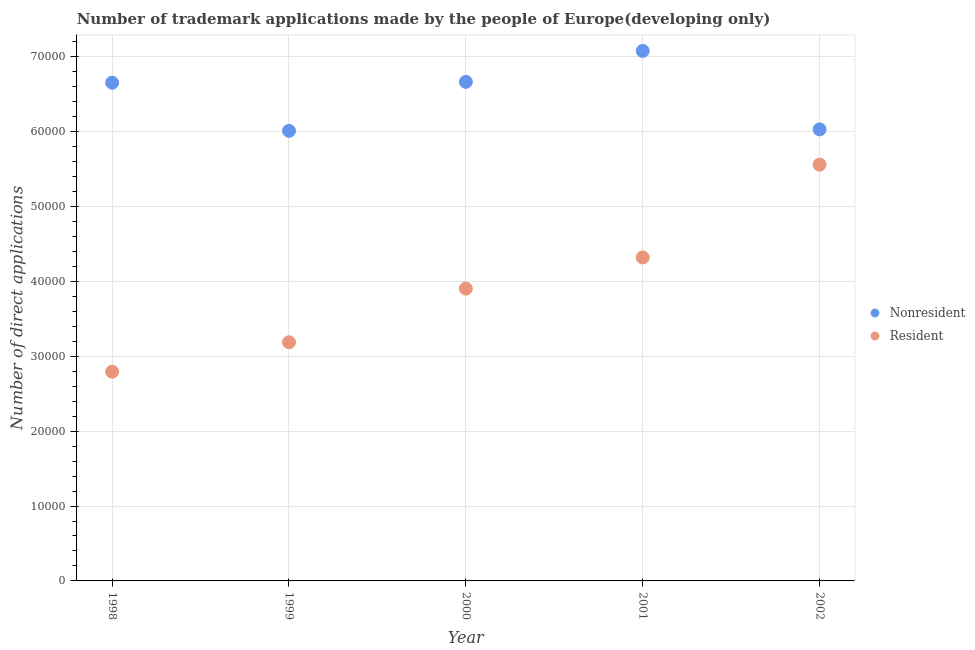What is the number of trademark applications made by residents in 2002?
Offer a very short reply. 5.56e+04. Across all years, what is the maximum number of trademark applications made by residents?
Your answer should be compact. 5.56e+04. Across all years, what is the minimum number of trademark applications made by residents?
Give a very brief answer. 2.79e+04. What is the total number of trademark applications made by residents in the graph?
Keep it short and to the point. 1.98e+05. What is the difference between the number of trademark applications made by non residents in 2001 and that in 2002?
Your response must be concise. 1.05e+04. What is the difference between the number of trademark applications made by residents in 2001 and the number of trademark applications made by non residents in 2000?
Provide a succinct answer. -2.35e+04. What is the average number of trademark applications made by residents per year?
Provide a short and direct response. 3.95e+04. In the year 2002, what is the difference between the number of trademark applications made by non residents and number of trademark applications made by residents?
Provide a succinct answer. 4712. What is the ratio of the number of trademark applications made by residents in 1999 to that in 2000?
Your response must be concise. 0.82. Is the number of trademark applications made by non residents in 2000 less than that in 2002?
Your response must be concise. No. What is the difference between the highest and the second highest number of trademark applications made by non residents?
Make the answer very short. 4131. What is the difference between the highest and the lowest number of trademark applications made by non residents?
Your answer should be very brief. 1.07e+04. Does the graph contain any zero values?
Your answer should be very brief. No. Does the graph contain grids?
Keep it short and to the point. Yes. Where does the legend appear in the graph?
Provide a short and direct response. Center right. How many legend labels are there?
Give a very brief answer. 2. What is the title of the graph?
Provide a succinct answer. Number of trademark applications made by the people of Europe(developing only). Does "Domestic Liabilities" appear as one of the legend labels in the graph?
Provide a succinct answer. No. What is the label or title of the Y-axis?
Your answer should be compact. Number of direct applications. What is the Number of direct applications of Nonresident in 1998?
Make the answer very short. 6.65e+04. What is the Number of direct applications of Resident in 1998?
Your answer should be very brief. 2.79e+04. What is the Number of direct applications of Nonresident in 1999?
Your answer should be very brief. 6.01e+04. What is the Number of direct applications of Resident in 1999?
Give a very brief answer. 3.19e+04. What is the Number of direct applications of Nonresident in 2000?
Provide a short and direct response. 6.66e+04. What is the Number of direct applications of Resident in 2000?
Your answer should be very brief. 3.90e+04. What is the Number of direct applications of Nonresident in 2001?
Provide a succinct answer. 7.08e+04. What is the Number of direct applications of Resident in 2001?
Provide a short and direct response. 4.32e+04. What is the Number of direct applications of Nonresident in 2002?
Your answer should be very brief. 6.03e+04. What is the Number of direct applications of Resident in 2002?
Give a very brief answer. 5.56e+04. Across all years, what is the maximum Number of direct applications in Nonresident?
Ensure brevity in your answer.  7.08e+04. Across all years, what is the maximum Number of direct applications in Resident?
Make the answer very short. 5.56e+04. Across all years, what is the minimum Number of direct applications in Nonresident?
Offer a very short reply. 6.01e+04. Across all years, what is the minimum Number of direct applications of Resident?
Offer a terse response. 2.79e+04. What is the total Number of direct applications in Nonresident in the graph?
Your answer should be very brief. 3.24e+05. What is the total Number of direct applications of Resident in the graph?
Give a very brief answer. 1.98e+05. What is the difference between the Number of direct applications in Nonresident in 1998 and that in 1999?
Ensure brevity in your answer.  6429. What is the difference between the Number of direct applications of Resident in 1998 and that in 1999?
Make the answer very short. -3927. What is the difference between the Number of direct applications of Nonresident in 1998 and that in 2000?
Your answer should be very brief. -114. What is the difference between the Number of direct applications in Resident in 1998 and that in 2000?
Offer a terse response. -1.11e+04. What is the difference between the Number of direct applications of Nonresident in 1998 and that in 2001?
Provide a short and direct response. -4245. What is the difference between the Number of direct applications in Resident in 1998 and that in 2001?
Give a very brief answer. -1.53e+04. What is the difference between the Number of direct applications in Nonresident in 1998 and that in 2002?
Your response must be concise. 6230. What is the difference between the Number of direct applications of Resident in 1998 and that in 2002?
Give a very brief answer. -2.77e+04. What is the difference between the Number of direct applications of Nonresident in 1999 and that in 2000?
Keep it short and to the point. -6543. What is the difference between the Number of direct applications of Resident in 1999 and that in 2000?
Ensure brevity in your answer.  -7171. What is the difference between the Number of direct applications in Nonresident in 1999 and that in 2001?
Provide a succinct answer. -1.07e+04. What is the difference between the Number of direct applications in Resident in 1999 and that in 2001?
Offer a terse response. -1.13e+04. What is the difference between the Number of direct applications in Nonresident in 1999 and that in 2002?
Your response must be concise. -199. What is the difference between the Number of direct applications of Resident in 1999 and that in 2002?
Ensure brevity in your answer.  -2.37e+04. What is the difference between the Number of direct applications of Nonresident in 2000 and that in 2001?
Provide a succinct answer. -4131. What is the difference between the Number of direct applications in Resident in 2000 and that in 2001?
Your response must be concise. -4157. What is the difference between the Number of direct applications in Nonresident in 2000 and that in 2002?
Offer a terse response. 6344. What is the difference between the Number of direct applications in Resident in 2000 and that in 2002?
Offer a very short reply. -1.66e+04. What is the difference between the Number of direct applications in Nonresident in 2001 and that in 2002?
Make the answer very short. 1.05e+04. What is the difference between the Number of direct applications in Resident in 2001 and that in 2002?
Provide a short and direct response. -1.24e+04. What is the difference between the Number of direct applications of Nonresident in 1998 and the Number of direct applications of Resident in 1999?
Your response must be concise. 3.47e+04. What is the difference between the Number of direct applications of Nonresident in 1998 and the Number of direct applications of Resident in 2000?
Provide a short and direct response. 2.75e+04. What is the difference between the Number of direct applications of Nonresident in 1998 and the Number of direct applications of Resident in 2001?
Make the answer very short. 2.33e+04. What is the difference between the Number of direct applications in Nonresident in 1998 and the Number of direct applications in Resident in 2002?
Your answer should be very brief. 1.09e+04. What is the difference between the Number of direct applications in Nonresident in 1999 and the Number of direct applications in Resident in 2000?
Ensure brevity in your answer.  2.11e+04. What is the difference between the Number of direct applications in Nonresident in 1999 and the Number of direct applications in Resident in 2001?
Make the answer very short. 1.69e+04. What is the difference between the Number of direct applications in Nonresident in 1999 and the Number of direct applications in Resident in 2002?
Provide a short and direct response. 4513. What is the difference between the Number of direct applications of Nonresident in 2000 and the Number of direct applications of Resident in 2001?
Keep it short and to the point. 2.35e+04. What is the difference between the Number of direct applications in Nonresident in 2000 and the Number of direct applications in Resident in 2002?
Keep it short and to the point. 1.11e+04. What is the difference between the Number of direct applications in Nonresident in 2001 and the Number of direct applications in Resident in 2002?
Your answer should be very brief. 1.52e+04. What is the average Number of direct applications of Nonresident per year?
Offer a terse response. 6.49e+04. What is the average Number of direct applications in Resident per year?
Offer a very short reply. 3.95e+04. In the year 1998, what is the difference between the Number of direct applications in Nonresident and Number of direct applications in Resident?
Your answer should be compact. 3.86e+04. In the year 1999, what is the difference between the Number of direct applications in Nonresident and Number of direct applications in Resident?
Your answer should be compact. 2.82e+04. In the year 2000, what is the difference between the Number of direct applications in Nonresident and Number of direct applications in Resident?
Keep it short and to the point. 2.76e+04. In the year 2001, what is the difference between the Number of direct applications of Nonresident and Number of direct applications of Resident?
Keep it short and to the point. 2.76e+04. In the year 2002, what is the difference between the Number of direct applications in Nonresident and Number of direct applications in Resident?
Keep it short and to the point. 4712. What is the ratio of the Number of direct applications in Nonresident in 1998 to that in 1999?
Your answer should be very brief. 1.11. What is the ratio of the Number of direct applications in Resident in 1998 to that in 1999?
Your answer should be compact. 0.88. What is the ratio of the Number of direct applications of Nonresident in 1998 to that in 2000?
Ensure brevity in your answer.  1. What is the ratio of the Number of direct applications of Resident in 1998 to that in 2000?
Offer a very short reply. 0.72. What is the ratio of the Number of direct applications in Nonresident in 1998 to that in 2001?
Provide a succinct answer. 0.94. What is the ratio of the Number of direct applications in Resident in 1998 to that in 2001?
Make the answer very short. 0.65. What is the ratio of the Number of direct applications of Nonresident in 1998 to that in 2002?
Keep it short and to the point. 1.1. What is the ratio of the Number of direct applications in Resident in 1998 to that in 2002?
Keep it short and to the point. 0.5. What is the ratio of the Number of direct applications in Nonresident in 1999 to that in 2000?
Offer a very short reply. 0.9. What is the ratio of the Number of direct applications in Resident in 1999 to that in 2000?
Your answer should be very brief. 0.82. What is the ratio of the Number of direct applications of Nonresident in 1999 to that in 2001?
Offer a terse response. 0.85. What is the ratio of the Number of direct applications of Resident in 1999 to that in 2001?
Keep it short and to the point. 0.74. What is the ratio of the Number of direct applications of Resident in 1999 to that in 2002?
Give a very brief answer. 0.57. What is the ratio of the Number of direct applications of Nonresident in 2000 to that in 2001?
Keep it short and to the point. 0.94. What is the ratio of the Number of direct applications of Resident in 2000 to that in 2001?
Offer a terse response. 0.9. What is the ratio of the Number of direct applications of Nonresident in 2000 to that in 2002?
Your answer should be compact. 1.11. What is the ratio of the Number of direct applications in Resident in 2000 to that in 2002?
Ensure brevity in your answer.  0.7. What is the ratio of the Number of direct applications in Nonresident in 2001 to that in 2002?
Your answer should be very brief. 1.17. What is the ratio of the Number of direct applications of Resident in 2001 to that in 2002?
Offer a very short reply. 0.78. What is the difference between the highest and the second highest Number of direct applications in Nonresident?
Keep it short and to the point. 4131. What is the difference between the highest and the second highest Number of direct applications in Resident?
Make the answer very short. 1.24e+04. What is the difference between the highest and the lowest Number of direct applications of Nonresident?
Make the answer very short. 1.07e+04. What is the difference between the highest and the lowest Number of direct applications of Resident?
Keep it short and to the point. 2.77e+04. 